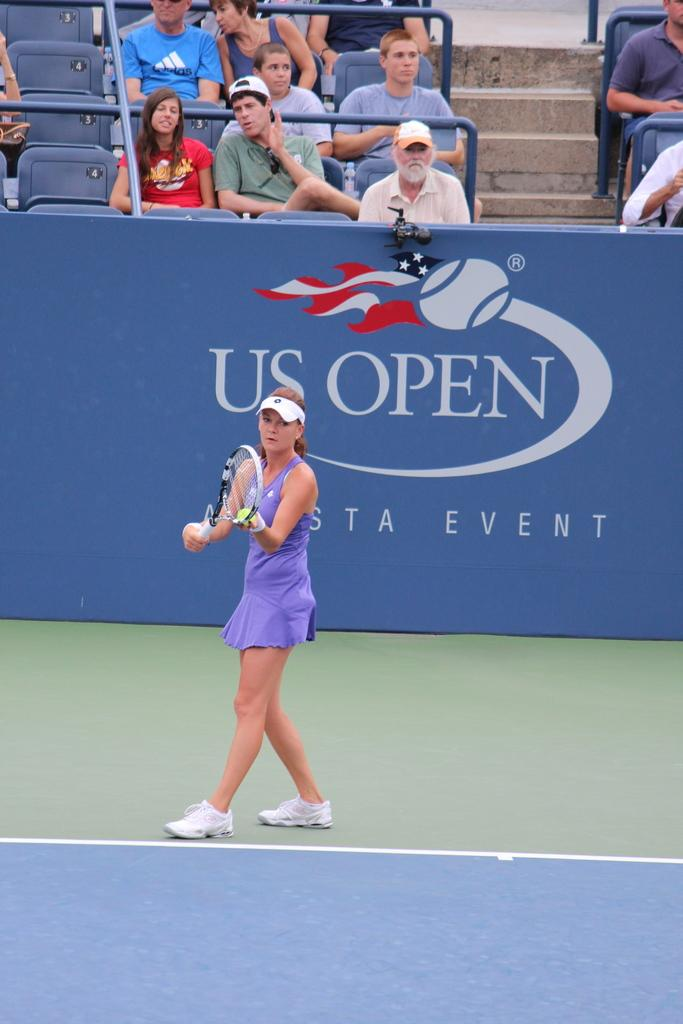Who is the main subject in the image? There is a woman in the image. What is the woman doing in the image? The woman is playing tennis. What tool is the woman using to play tennis? The woman is using a tennis racket. Can you describe the scene in the background of the image? There are people in the background of the image, and they are watching the woman play tennis. What type of rabbit can be seen hopping on the tennis court in the image? There is no rabbit present in the image; it features a woman playing tennis. Can you tell me how many grains of sand are on the tennis court in the image? There is no mention of sand or grains in the image, so it is impossible to determine the number of grains on the tennis court. 